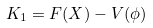Convert formula to latex. <formula><loc_0><loc_0><loc_500><loc_500>K _ { 1 } = F ( X ) - V ( \phi )</formula> 